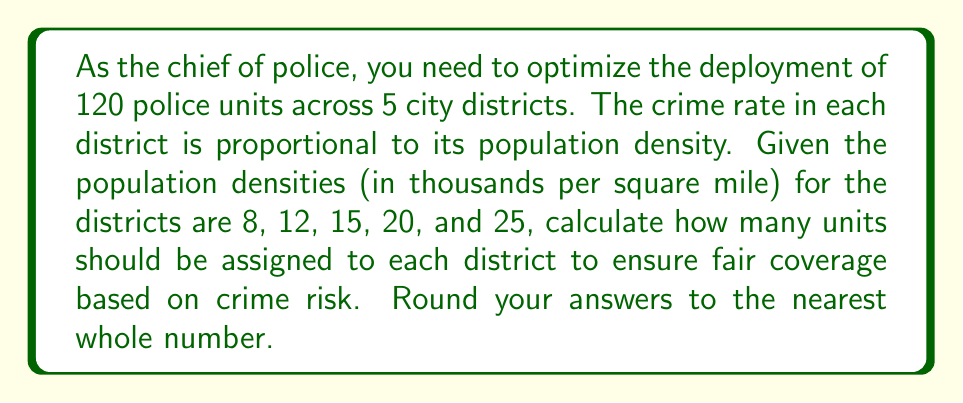Teach me how to tackle this problem. To solve this problem, we'll follow these steps:

1) Calculate the total population density:
   $$ 8 + 12 + 15 + 20 + 25 = 80 $$

2) Calculate the fraction of total density for each district:
   District 1: $\frac{8}{80} = 0.1$
   District 2: $\frac{12}{80} = 0.15$
   District 3: $\frac{15}{80} = 0.1875$
   District 4: $\frac{20}{80} = 0.25$
   District 5: $\frac{25}{80} = 0.3125$

3) Multiply the total number of units (120) by each fraction:
   District 1: $120 \times 0.1 = 12$
   District 2: $120 \times 0.15 = 18$
   District 3: $120 \times 0.1875 = 22.5$
   District 4: $120 \times 0.25 = 30$
   District 5: $120 \times 0.3125 = 37.5$

4) Round to the nearest whole number:
   District 1: 12
   District 2: 18
   District 3: 23
   District 4: 30
   District 5: 38

This distribution ensures that each district receives a number of police units proportional to its population density, which is assumed to correlate with the crime rate.
Answer: 12, 18, 23, 30, 38 